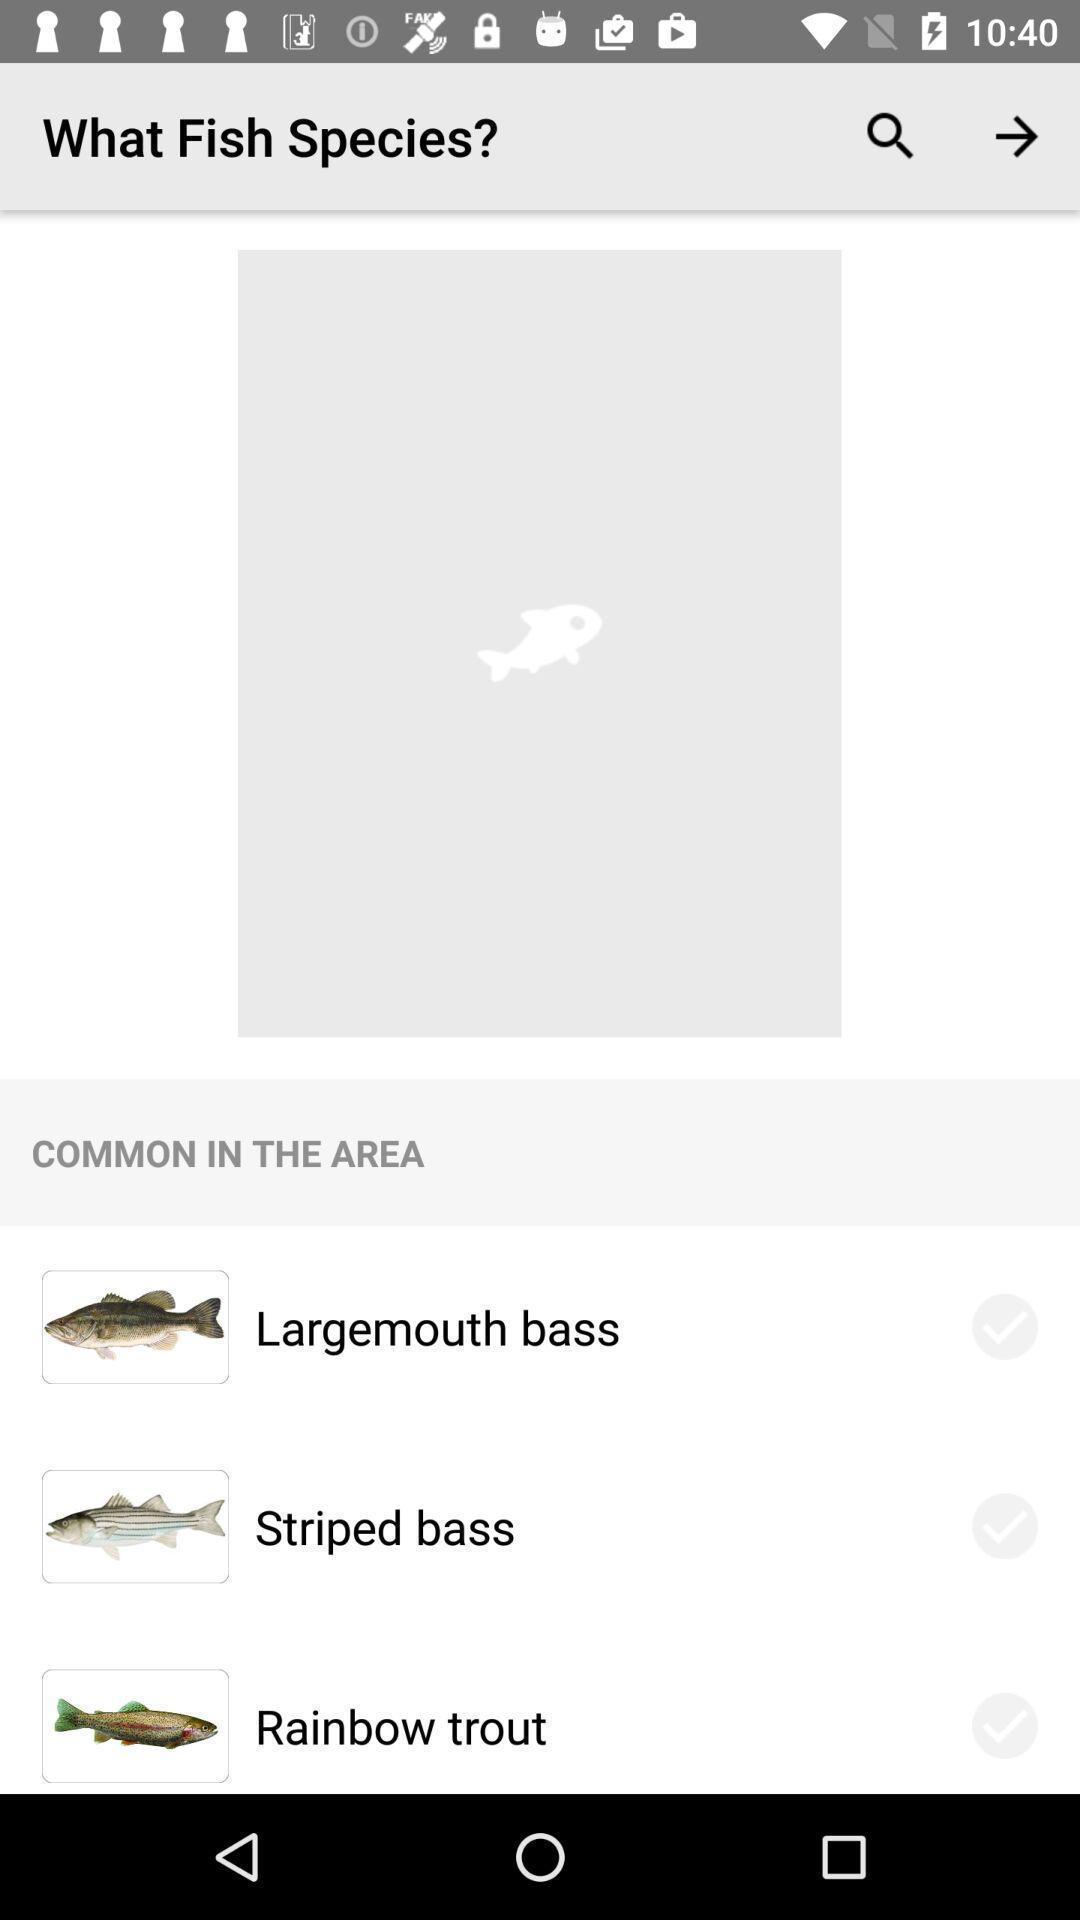What can you discern from this picture? Screen shows different fish species. 